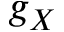Convert formula to latex. <formula><loc_0><loc_0><loc_500><loc_500>g _ { X }</formula> 